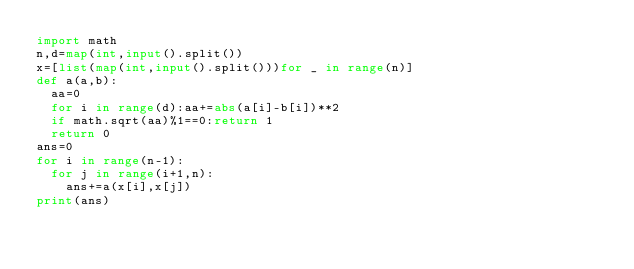<code> <loc_0><loc_0><loc_500><loc_500><_Python_>import math
n,d=map(int,input().split())
x=[list(map(int,input().split()))for _ in range(n)]
def a(a,b):
  aa=0
  for i in range(d):aa+=abs(a[i]-b[i])**2
  if math.sqrt(aa)%1==0:return 1
  return 0
ans=0
for i in range(n-1):
  for j in range(i+1,n):
    ans+=a(x[i],x[j])
print(ans)</code> 